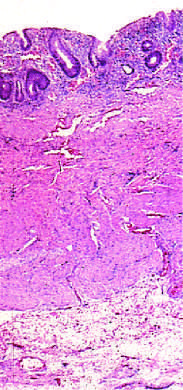s masson trichrome limited to the mucosa?
Answer the question using a single word or phrase. No 